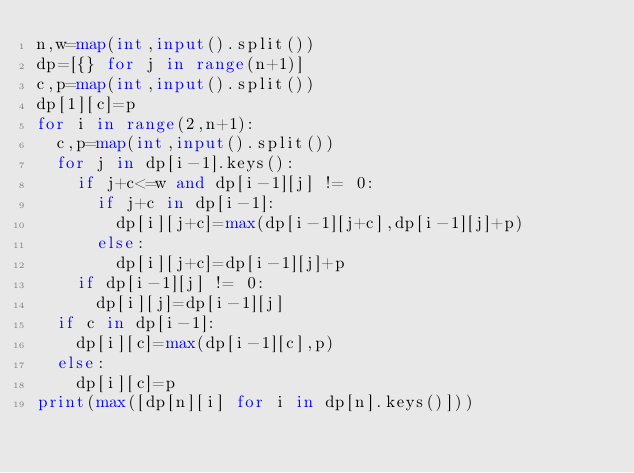Convert code to text. <code><loc_0><loc_0><loc_500><loc_500><_Python_>n,w=map(int,input().split())
dp=[{} for j in range(n+1)]
c,p=map(int,input().split())
dp[1][c]=p
for i in range(2,n+1):
  c,p=map(int,input().split())
  for j in dp[i-1].keys():
    if j+c<=w and dp[i-1][j] != 0:
      if j+c in dp[i-1]:
        dp[i][j+c]=max(dp[i-1][j+c],dp[i-1][j]+p)
      else:
        dp[i][j+c]=dp[i-1][j]+p
    if dp[i-1][j] != 0:
      dp[i][j]=dp[i-1][j]
  if c in dp[i-1]:
    dp[i][c]=max(dp[i-1][c],p)
  else:
    dp[i][c]=p
print(max([dp[n][i] for i in dp[n].keys()]))</code> 